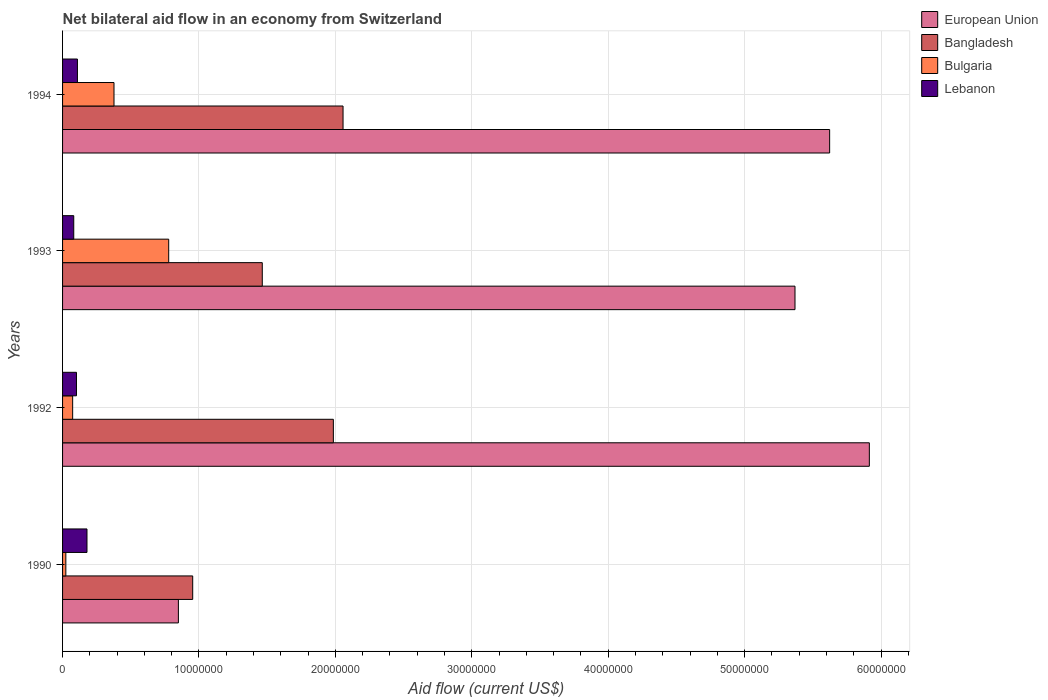Are the number of bars on each tick of the Y-axis equal?
Provide a succinct answer. Yes. How many bars are there on the 3rd tick from the top?
Make the answer very short. 4. What is the label of the 1st group of bars from the top?
Keep it short and to the point. 1994. In how many cases, is the number of bars for a given year not equal to the number of legend labels?
Make the answer very short. 0. What is the net bilateral aid flow in Bangladesh in 1990?
Provide a succinct answer. 9.54e+06. Across all years, what is the maximum net bilateral aid flow in Bulgaria?
Your answer should be compact. 7.78e+06. Across all years, what is the minimum net bilateral aid flow in Lebanon?
Ensure brevity in your answer.  8.20e+05. In which year was the net bilateral aid flow in Bangladesh maximum?
Give a very brief answer. 1994. What is the total net bilateral aid flow in Lebanon in the graph?
Make the answer very short. 4.72e+06. What is the difference between the net bilateral aid flow in Lebanon in 1992 and that in 1994?
Offer a very short reply. -7.00e+04. What is the difference between the net bilateral aid flow in Bulgaria in 1993 and the net bilateral aid flow in European Union in 1992?
Your answer should be very brief. -5.14e+07. What is the average net bilateral aid flow in Lebanon per year?
Provide a succinct answer. 1.18e+06. In the year 1992, what is the difference between the net bilateral aid flow in European Union and net bilateral aid flow in Lebanon?
Ensure brevity in your answer.  5.81e+07. What is the ratio of the net bilateral aid flow in Lebanon in 1993 to that in 1994?
Make the answer very short. 0.75. Is the difference between the net bilateral aid flow in European Union in 1992 and 1994 greater than the difference between the net bilateral aid flow in Lebanon in 1992 and 1994?
Your answer should be very brief. Yes. What is the difference between the highest and the second highest net bilateral aid flow in Bulgaria?
Your answer should be compact. 4.01e+06. What is the difference between the highest and the lowest net bilateral aid flow in Bangladesh?
Make the answer very short. 1.10e+07. What does the 1st bar from the bottom in 1993 represents?
Give a very brief answer. European Union. Is it the case that in every year, the sum of the net bilateral aid flow in Lebanon and net bilateral aid flow in European Union is greater than the net bilateral aid flow in Bulgaria?
Your answer should be very brief. Yes. How many bars are there?
Your answer should be compact. 16. Are all the bars in the graph horizontal?
Your response must be concise. Yes. Does the graph contain grids?
Your answer should be compact. Yes. Where does the legend appear in the graph?
Offer a very short reply. Top right. How many legend labels are there?
Make the answer very short. 4. How are the legend labels stacked?
Ensure brevity in your answer.  Vertical. What is the title of the graph?
Keep it short and to the point. Net bilateral aid flow in an economy from Switzerland. Does "Sao Tome and Principe" appear as one of the legend labels in the graph?
Your answer should be very brief. No. What is the label or title of the Y-axis?
Your response must be concise. Years. What is the Aid flow (current US$) of European Union in 1990?
Provide a succinct answer. 8.49e+06. What is the Aid flow (current US$) of Bangladesh in 1990?
Your response must be concise. 9.54e+06. What is the Aid flow (current US$) in Lebanon in 1990?
Ensure brevity in your answer.  1.79e+06. What is the Aid flow (current US$) in European Union in 1992?
Offer a very short reply. 5.91e+07. What is the Aid flow (current US$) in Bangladesh in 1992?
Ensure brevity in your answer.  1.98e+07. What is the Aid flow (current US$) of Bulgaria in 1992?
Your answer should be very brief. 7.40e+05. What is the Aid flow (current US$) of Lebanon in 1992?
Make the answer very short. 1.02e+06. What is the Aid flow (current US$) in European Union in 1993?
Your answer should be compact. 5.37e+07. What is the Aid flow (current US$) in Bangladesh in 1993?
Provide a short and direct response. 1.46e+07. What is the Aid flow (current US$) in Bulgaria in 1993?
Offer a very short reply. 7.78e+06. What is the Aid flow (current US$) in Lebanon in 1993?
Make the answer very short. 8.20e+05. What is the Aid flow (current US$) in European Union in 1994?
Keep it short and to the point. 5.62e+07. What is the Aid flow (current US$) of Bangladesh in 1994?
Provide a succinct answer. 2.06e+07. What is the Aid flow (current US$) in Bulgaria in 1994?
Your answer should be compact. 3.77e+06. What is the Aid flow (current US$) of Lebanon in 1994?
Provide a short and direct response. 1.09e+06. Across all years, what is the maximum Aid flow (current US$) in European Union?
Offer a terse response. 5.91e+07. Across all years, what is the maximum Aid flow (current US$) in Bangladesh?
Make the answer very short. 2.06e+07. Across all years, what is the maximum Aid flow (current US$) in Bulgaria?
Your response must be concise. 7.78e+06. Across all years, what is the maximum Aid flow (current US$) of Lebanon?
Your answer should be compact. 1.79e+06. Across all years, what is the minimum Aid flow (current US$) in European Union?
Keep it short and to the point. 8.49e+06. Across all years, what is the minimum Aid flow (current US$) in Bangladesh?
Provide a succinct answer. 9.54e+06. Across all years, what is the minimum Aid flow (current US$) in Bulgaria?
Keep it short and to the point. 2.40e+05. Across all years, what is the minimum Aid flow (current US$) in Lebanon?
Your answer should be compact. 8.20e+05. What is the total Aid flow (current US$) of European Union in the graph?
Your answer should be compact. 1.78e+08. What is the total Aid flow (current US$) of Bangladesh in the graph?
Keep it short and to the point. 6.46e+07. What is the total Aid flow (current US$) of Bulgaria in the graph?
Provide a succinct answer. 1.25e+07. What is the total Aid flow (current US$) in Lebanon in the graph?
Provide a short and direct response. 4.72e+06. What is the difference between the Aid flow (current US$) of European Union in 1990 and that in 1992?
Offer a very short reply. -5.06e+07. What is the difference between the Aid flow (current US$) in Bangladesh in 1990 and that in 1992?
Keep it short and to the point. -1.03e+07. What is the difference between the Aid flow (current US$) of Bulgaria in 1990 and that in 1992?
Give a very brief answer. -5.00e+05. What is the difference between the Aid flow (current US$) of Lebanon in 1990 and that in 1992?
Provide a short and direct response. 7.70e+05. What is the difference between the Aid flow (current US$) in European Union in 1990 and that in 1993?
Offer a very short reply. -4.52e+07. What is the difference between the Aid flow (current US$) of Bangladesh in 1990 and that in 1993?
Ensure brevity in your answer.  -5.10e+06. What is the difference between the Aid flow (current US$) of Bulgaria in 1990 and that in 1993?
Make the answer very short. -7.54e+06. What is the difference between the Aid flow (current US$) of Lebanon in 1990 and that in 1993?
Keep it short and to the point. 9.70e+05. What is the difference between the Aid flow (current US$) in European Union in 1990 and that in 1994?
Offer a terse response. -4.77e+07. What is the difference between the Aid flow (current US$) in Bangladesh in 1990 and that in 1994?
Ensure brevity in your answer.  -1.10e+07. What is the difference between the Aid flow (current US$) of Bulgaria in 1990 and that in 1994?
Ensure brevity in your answer.  -3.53e+06. What is the difference between the Aid flow (current US$) of European Union in 1992 and that in 1993?
Make the answer very short. 5.45e+06. What is the difference between the Aid flow (current US$) in Bangladesh in 1992 and that in 1993?
Keep it short and to the point. 5.21e+06. What is the difference between the Aid flow (current US$) of Bulgaria in 1992 and that in 1993?
Offer a terse response. -7.04e+06. What is the difference between the Aid flow (current US$) of European Union in 1992 and that in 1994?
Give a very brief answer. 2.91e+06. What is the difference between the Aid flow (current US$) in Bangladesh in 1992 and that in 1994?
Provide a short and direct response. -7.10e+05. What is the difference between the Aid flow (current US$) in Bulgaria in 1992 and that in 1994?
Give a very brief answer. -3.03e+06. What is the difference between the Aid flow (current US$) of European Union in 1993 and that in 1994?
Keep it short and to the point. -2.54e+06. What is the difference between the Aid flow (current US$) of Bangladesh in 1993 and that in 1994?
Make the answer very short. -5.92e+06. What is the difference between the Aid flow (current US$) of Bulgaria in 1993 and that in 1994?
Your answer should be compact. 4.01e+06. What is the difference between the Aid flow (current US$) of Lebanon in 1993 and that in 1994?
Your answer should be compact. -2.70e+05. What is the difference between the Aid flow (current US$) in European Union in 1990 and the Aid flow (current US$) in Bangladesh in 1992?
Provide a succinct answer. -1.14e+07. What is the difference between the Aid flow (current US$) in European Union in 1990 and the Aid flow (current US$) in Bulgaria in 1992?
Ensure brevity in your answer.  7.75e+06. What is the difference between the Aid flow (current US$) of European Union in 1990 and the Aid flow (current US$) of Lebanon in 1992?
Your response must be concise. 7.47e+06. What is the difference between the Aid flow (current US$) in Bangladesh in 1990 and the Aid flow (current US$) in Bulgaria in 1992?
Your answer should be very brief. 8.80e+06. What is the difference between the Aid flow (current US$) of Bangladesh in 1990 and the Aid flow (current US$) of Lebanon in 1992?
Give a very brief answer. 8.52e+06. What is the difference between the Aid flow (current US$) of Bulgaria in 1990 and the Aid flow (current US$) of Lebanon in 1992?
Offer a terse response. -7.80e+05. What is the difference between the Aid flow (current US$) in European Union in 1990 and the Aid flow (current US$) in Bangladesh in 1993?
Your answer should be very brief. -6.15e+06. What is the difference between the Aid flow (current US$) of European Union in 1990 and the Aid flow (current US$) of Bulgaria in 1993?
Ensure brevity in your answer.  7.10e+05. What is the difference between the Aid flow (current US$) in European Union in 1990 and the Aid flow (current US$) in Lebanon in 1993?
Your answer should be compact. 7.67e+06. What is the difference between the Aid flow (current US$) in Bangladesh in 1990 and the Aid flow (current US$) in Bulgaria in 1993?
Your answer should be compact. 1.76e+06. What is the difference between the Aid flow (current US$) in Bangladesh in 1990 and the Aid flow (current US$) in Lebanon in 1993?
Your answer should be very brief. 8.72e+06. What is the difference between the Aid flow (current US$) of Bulgaria in 1990 and the Aid flow (current US$) of Lebanon in 1993?
Keep it short and to the point. -5.80e+05. What is the difference between the Aid flow (current US$) of European Union in 1990 and the Aid flow (current US$) of Bangladesh in 1994?
Your answer should be compact. -1.21e+07. What is the difference between the Aid flow (current US$) in European Union in 1990 and the Aid flow (current US$) in Bulgaria in 1994?
Keep it short and to the point. 4.72e+06. What is the difference between the Aid flow (current US$) of European Union in 1990 and the Aid flow (current US$) of Lebanon in 1994?
Your response must be concise. 7.40e+06. What is the difference between the Aid flow (current US$) of Bangladesh in 1990 and the Aid flow (current US$) of Bulgaria in 1994?
Keep it short and to the point. 5.77e+06. What is the difference between the Aid flow (current US$) in Bangladesh in 1990 and the Aid flow (current US$) in Lebanon in 1994?
Provide a succinct answer. 8.45e+06. What is the difference between the Aid flow (current US$) in Bulgaria in 1990 and the Aid flow (current US$) in Lebanon in 1994?
Your answer should be very brief. -8.50e+05. What is the difference between the Aid flow (current US$) in European Union in 1992 and the Aid flow (current US$) in Bangladesh in 1993?
Ensure brevity in your answer.  4.45e+07. What is the difference between the Aid flow (current US$) in European Union in 1992 and the Aid flow (current US$) in Bulgaria in 1993?
Your answer should be compact. 5.14e+07. What is the difference between the Aid flow (current US$) of European Union in 1992 and the Aid flow (current US$) of Lebanon in 1993?
Give a very brief answer. 5.83e+07. What is the difference between the Aid flow (current US$) of Bangladesh in 1992 and the Aid flow (current US$) of Bulgaria in 1993?
Keep it short and to the point. 1.21e+07. What is the difference between the Aid flow (current US$) of Bangladesh in 1992 and the Aid flow (current US$) of Lebanon in 1993?
Keep it short and to the point. 1.90e+07. What is the difference between the Aid flow (current US$) in European Union in 1992 and the Aid flow (current US$) in Bangladesh in 1994?
Offer a very short reply. 3.86e+07. What is the difference between the Aid flow (current US$) of European Union in 1992 and the Aid flow (current US$) of Bulgaria in 1994?
Your answer should be compact. 5.54e+07. What is the difference between the Aid flow (current US$) in European Union in 1992 and the Aid flow (current US$) in Lebanon in 1994?
Offer a very short reply. 5.80e+07. What is the difference between the Aid flow (current US$) in Bangladesh in 1992 and the Aid flow (current US$) in Bulgaria in 1994?
Provide a short and direct response. 1.61e+07. What is the difference between the Aid flow (current US$) in Bangladesh in 1992 and the Aid flow (current US$) in Lebanon in 1994?
Your response must be concise. 1.88e+07. What is the difference between the Aid flow (current US$) in Bulgaria in 1992 and the Aid flow (current US$) in Lebanon in 1994?
Provide a short and direct response. -3.50e+05. What is the difference between the Aid flow (current US$) of European Union in 1993 and the Aid flow (current US$) of Bangladesh in 1994?
Keep it short and to the point. 3.31e+07. What is the difference between the Aid flow (current US$) of European Union in 1993 and the Aid flow (current US$) of Bulgaria in 1994?
Your response must be concise. 4.99e+07. What is the difference between the Aid flow (current US$) in European Union in 1993 and the Aid flow (current US$) in Lebanon in 1994?
Give a very brief answer. 5.26e+07. What is the difference between the Aid flow (current US$) of Bangladesh in 1993 and the Aid flow (current US$) of Bulgaria in 1994?
Make the answer very short. 1.09e+07. What is the difference between the Aid flow (current US$) in Bangladesh in 1993 and the Aid flow (current US$) in Lebanon in 1994?
Offer a very short reply. 1.36e+07. What is the difference between the Aid flow (current US$) in Bulgaria in 1993 and the Aid flow (current US$) in Lebanon in 1994?
Provide a short and direct response. 6.69e+06. What is the average Aid flow (current US$) in European Union per year?
Offer a very short reply. 4.44e+07. What is the average Aid flow (current US$) of Bangladesh per year?
Offer a very short reply. 1.61e+07. What is the average Aid flow (current US$) in Bulgaria per year?
Give a very brief answer. 3.13e+06. What is the average Aid flow (current US$) of Lebanon per year?
Offer a very short reply. 1.18e+06. In the year 1990, what is the difference between the Aid flow (current US$) of European Union and Aid flow (current US$) of Bangladesh?
Your answer should be compact. -1.05e+06. In the year 1990, what is the difference between the Aid flow (current US$) of European Union and Aid flow (current US$) of Bulgaria?
Give a very brief answer. 8.25e+06. In the year 1990, what is the difference between the Aid flow (current US$) of European Union and Aid flow (current US$) of Lebanon?
Your response must be concise. 6.70e+06. In the year 1990, what is the difference between the Aid flow (current US$) in Bangladesh and Aid flow (current US$) in Bulgaria?
Ensure brevity in your answer.  9.30e+06. In the year 1990, what is the difference between the Aid flow (current US$) of Bangladesh and Aid flow (current US$) of Lebanon?
Your response must be concise. 7.75e+06. In the year 1990, what is the difference between the Aid flow (current US$) of Bulgaria and Aid flow (current US$) of Lebanon?
Provide a short and direct response. -1.55e+06. In the year 1992, what is the difference between the Aid flow (current US$) of European Union and Aid flow (current US$) of Bangladesh?
Your response must be concise. 3.93e+07. In the year 1992, what is the difference between the Aid flow (current US$) in European Union and Aid flow (current US$) in Bulgaria?
Provide a succinct answer. 5.84e+07. In the year 1992, what is the difference between the Aid flow (current US$) of European Union and Aid flow (current US$) of Lebanon?
Provide a succinct answer. 5.81e+07. In the year 1992, what is the difference between the Aid flow (current US$) in Bangladesh and Aid flow (current US$) in Bulgaria?
Offer a very short reply. 1.91e+07. In the year 1992, what is the difference between the Aid flow (current US$) in Bangladesh and Aid flow (current US$) in Lebanon?
Your answer should be very brief. 1.88e+07. In the year 1992, what is the difference between the Aid flow (current US$) of Bulgaria and Aid flow (current US$) of Lebanon?
Keep it short and to the point. -2.80e+05. In the year 1993, what is the difference between the Aid flow (current US$) of European Union and Aid flow (current US$) of Bangladesh?
Provide a succinct answer. 3.90e+07. In the year 1993, what is the difference between the Aid flow (current US$) of European Union and Aid flow (current US$) of Bulgaria?
Give a very brief answer. 4.59e+07. In the year 1993, what is the difference between the Aid flow (current US$) of European Union and Aid flow (current US$) of Lebanon?
Provide a succinct answer. 5.29e+07. In the year 1993, what is the difference between the Aid flow (current US$) in Bangladesh and Aid flow (current US$) in Bulgaria?
Offer a very short reply. 6.86e+06. In the year 1993, what is the difference between the Aid flow (current US$) in Bangladesh and Aid flow (current US$) in Lebanon?
Keep it short and to the point. 1.38e+07. In the year 1993, what is the difference between the Aid flow (current US$) in Bulgaria and Aid flow (current US$) in Lebanon?
Offer a terse response. 6.96e+06. In the year 1994, what is the difference between the Aid flow (current US$) of European Union and Aid flow (current US$) of Bangladesh?
Offer a very short reply. 3.57e+07. In the year 1994, what is the difference between the Aid flow (current US$) of European Union and Aid flow (current US$) of Bulgaria?
Your response must be concise. 5.25e+07. In the year 1994, what is the difference between the Aid flow (current US$) in European Union and Aid flow (current US$) in Lebanon?
Your answer should be very brief. 5.51e+07. In the year 1994, what is the difference between the Aid flow (current US$) in Bangladesh and Aid flow (current US$) in Bulgaria?
Your answer should be very brief. 1.68e+07. In the year 1994, what is the difference between the Aid flow (current US$) in Bangladesh and Aid flow (current US$) in Lebanon?
Offer a very short reply. 1.95e+07. In the year 1994, what is the difference between the Aid flow (current US$) of Bulgaria and Aid flow (current US$) of Lebanon?
Keep it short and to the point. 2.68e+06. What is the ratio of the Aid flow (current US$) of European Union in 1990 to that in 1992?
Your response must be concise. 0.14. What is the ratio of the Aid flow (current US$) in Bangladesh in 1990 to that in 1992?
Provide a succinct answer. 0.48. What is the ratio of the Aid flow (current US$) in Bulgaria in 1990 to that in 1992?
Provide a short and direct response. 0.32. What is the ratio of the Aid flow (current US$) in Lebanon in 1990 to that in 1992?
Your response must be concise. 1.75. What is the ratio of the Aid flow (current US$) of European Union in 1990 to that in 1993?
Provide a short and direct response. 0.16. What is the ratio of the Aid flow (current US$) of Bangladesh in 1990 to that in 1993?
Offer a very short reply. 0.65. What is the ratio of the Aid flow (current US$) in Bulgaria in 1990 to that in 1993?
Keep it short and to the point. 0.03. What is the ratio of the Aid flow (current US$) of Lebanon in 1990 to that in 1993?
Ensure brevity in your answer.  2.18. What is the ratio of the Aid flow (current US$) of European Union in 1990 to that in 1994?
Provide a succinct answer. 0.15. What is the ratio of the Aid flow (current US$) in Bangladesh in 1990 to that in 1994?
Ensure brevity in your answer.  0.46. What is the ratio of the Aid flow (current US$) of Bulgaria in 1990 to that in 1994?
Ensure brevity in your answer.  0.06. What is the ratio of the Aid flow (current US$) in Lebanon in 1990 to that in 1994?
Give a very brief answer. 1.64. What is the ratio of the Aid flow (current US$) in European Union in 1992 to that in 1993?
Your response must be concise. 1.1. What is the ratio of the Aid flow (current US$) of Bangladesh in 1992 to that in 1993?
Give a very brief answer. 1.36. What is the ratio of the Aid flow (current US$) of Bulgaria in 1992 to that in 1993?
Your answer should be compact. 0.1. What is the ratio of the Aid flow (current US$) in Lebanon in 1992 to that in 1993?
Give a very brief answer. 1.24. What is the ratio of the Aid flow (current US$) of European Union in 1992 to that in 1994?
Provide a succinct answer. 1.05. What is the ratio of the Aid flow (current US$) of Bangladesh in 1992 to that in 1994?
Offer a very short reply. 0.97. What is the ratio of the Aid flow (current US$) of Bulgaria in 1992 to that in 1994?
Make the answer very short. 0.2. What is the ratio of the Aid flow (current US$) of Lebanon in 1992 to that in 1994?
Give a very brief answer. 0.94. What is the ratio of the Aid flow (current US$) of European Union in 1993 to that in 1994?
Your answer should be compact. 0.95. What is the ratio of the Aid flow (current US$) in Bangladesh in 1993 to that in 1994?
Offer a very short reply. 0.71. What is the ratio of the Aid flow (current US$) in Bulgaria in 1993 to that in 1994?
Provide a short and direct response. 2.06. What is the ratio of the Aid flow (current US$) in Lebanon in 1993 to that in 1994?
Your answer should be very brief. 0.75. What is the difference between the highest and the second highest Aid flow (current US$) of European Union?
Keep it short and to the point. 2.91e+06. What is the difference between the highest and the second highest Aid flow (current US$) in Bangladesh?
Offer a very short reply. 7.10e+05. What is the difference between the highest and the second highest Aid flow (current US$) in Bulgaria?
Ensure brevity in your answer.  4.01e+06. What is the difference between the highest and the lowest Aid flow (current US$) in European Union?
Give a very brief answer. 5.06e+07. What is the difference between the highest and the lowest Aid flow (current US$) in Bangladesh?
Keep it short and to the point. 1.10e+07. What is the difference between the highest and the lowest Aid flow (current US$) of Bulgaria?
Make the answer very short. 7.54e+06. What is the difference between the highest and the lowest Aid flow (current US$) in Lebanon?
Offer a terse response. 9.70e+05. 